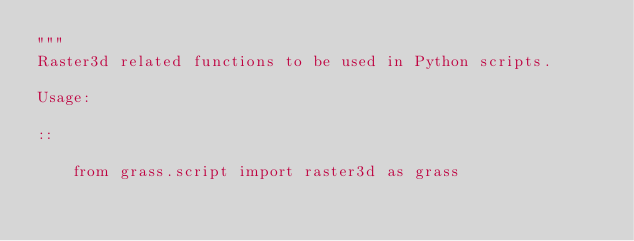<code> <loc_0><loc_0><loc_500><loc_500><_Python_>"""
Raster3d related functions to be used in Python scripts.

Usage:

::

    from grass.script import raster3d as grass</code> 